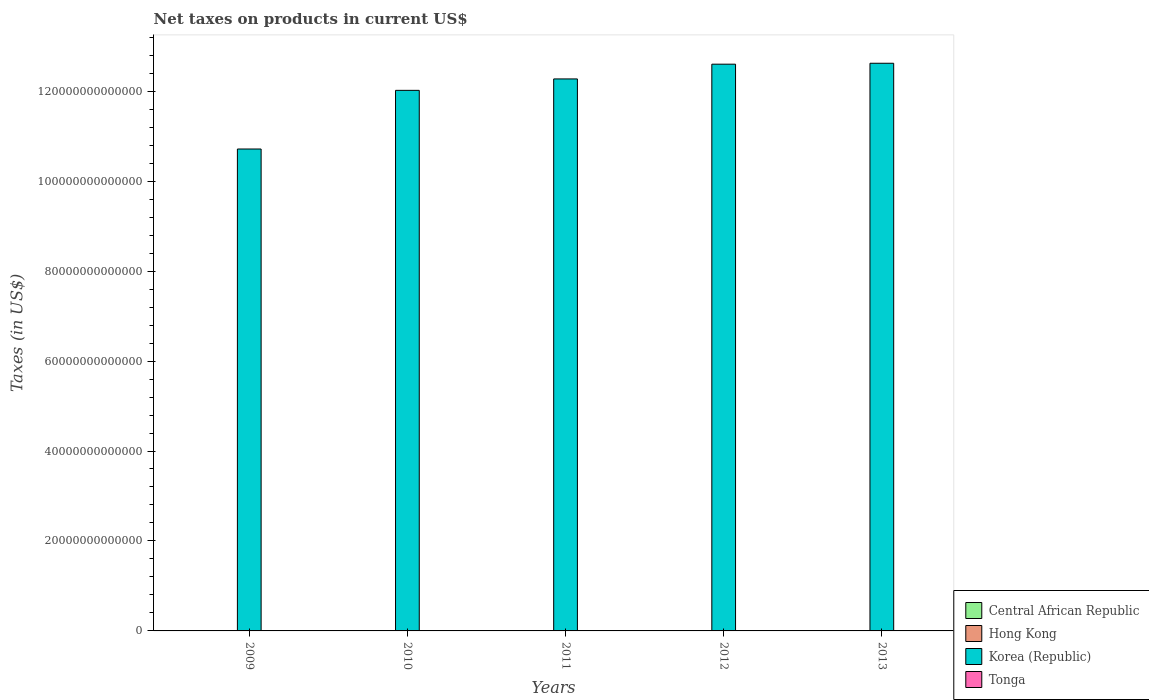How many groups of bars are there?
Provide a short and direct response. 5. Are the number of bars on each tick of the X-axis equal?
Your answer should be compact. Yes. What is the net taxes on products in Korea (Republic) in 2012?
Offer a terse response. 1.26e+14. Across all years, what is the maximum net taxes on products in Tonga?
Your response must be concise. 1.02e+08. Across all years, what is the minimum net taxes on products in Korea (Republic)?
Your response must be concise. 1.07e+14. In which year was the net taxes on products in Hong Kong maximum?
Provide a succinct answer. 2013. What is the total net taxes on products in Korea (Republic) in the graph?
Give a very brief answer. 6.02e+14. What is the difference between the net taxes on products in Hong Kong in 2009 and that in 2010?
Your answer should be compact. -1.40e+1. What is the difference between the net taxes on products in Hong Kong in 2009 and the net taxes on products in Central African Republic in 2012?
Give a very brief answer. -1.08e+1. What is the average net taxes on products in Hong Kong per year?
Your response must be concise. 6.63e+1. In the year 2011, what is the difference between the net taxes on products in Hong Kong and net taxes on products in Central African Republic?
Give a very brief answer. 1.40e+1. What is the ratio of the net taxes on products in Tonga in 2011 to that in 2012?
Offer a very short reply. 0.9. Is the net taxes on products in Central African Republic in 2010 less than that in 2013?
Your response must be concise. No. Is the difference between the net taxes on products in Hong Kong in 2009 and 2013 greater than the difference between the net taxes on products in Central African Republic in 2009 and 2013?
Give a very brief answer. No. What is the difference between the highest and the second highest net taxes on products in Korea (Republic)?
Keep it short and to the point. 2.06e+11. What is the difference between the highest and the lowest net taxes on products in Tonga?
Make the answer very short. 1.73e+07. Is the sum of the net taxes on products in Hong Kong in 2009 and 2010 greater than the maximum net taxes on products in Central African Republic across all years?
Your answer should be very brief. Yes. What does the 2nd bar from the left in 2009 represents?
Keep it short and to the point. Hong Kong. Is it the case that in every year, the sum of the net taxes on products in Tonga and net taxes on products in Hong Kong is greater than the net taxes on products in Korea (Republic)?
Your answer should be compact. No. How many bars are there?
Provide a short and direct response. 20. Are all the bars in the graph horizontal?
Provide a short and direct response. No. What is the difference between two consecutive major ticks on the Y-axis?
Offer a terse response. 2.00e+13. Does the graph contain any zero values?
Your answer should be very brief. No. Does the graph contain grids?
Provide a short and direct response. No. How are the legend labels stacked?
Offer a terse response. Vertical. What is the title of the graph?
Offer a terse response. Net taxes on products in current US$. What is the label or title of the X-axis?
Your answer should be compact. Years. What is the label or title of the Y-axis?
Provide a short and direct response. Taxes (in US$). What is the Taxes (in US$) of Central African Republic in 2009?
Keep it short and to the point. 6.08e+1. What is the Taxes (in US$) of Hong Kong in 2009?
Keep it short and to the point. 5.47e+1. What is the Taxes (in US$) of Korea (Republic) in 2009?
Your answer should be very brief. 1.07e+14. What is the Taxes (in US$) in Tonga in 2009?
Provide a short and direct response. 8.51e+07. What is the Taxes (in US$) in Central African Republic in 2010?
Your answer should be compact. 7.10e+1. What is the Taxes (in US$) in Hong Kong in 2010?
Your response must be concise. 6.87e+1. What is the Taxes (in US$) of Korea (Republic) in 2010?
Your answer should be compact. 1.20e+14. What is the Taxes (in US$) of Tonga in 2010?
Your response must be concise. 8.43e+07. What is the Taxes (in US$) in Central African Republic in 2011?
Your response must be concise. 5.54e+1. What is the Taxes (in US$) in Hong Kong in 2011?
Provide a succinct answer. 6.94e+1. What is the Taxes (in US$) in Korea (Republic) in 2011?
Keep it short and to the point. 1.23e+14. What is the Taxes (in US$) of Tonga in 2011?
Your answer should be compact. 9.14e+07. What is the Taxes (in US$) of Central African Republic in 2012?
Your response must be concise. 6.55e+1. What is the Taxes (in US$) in Hong Kong in 2012?
Keep it short and to the point. 6.36e+1. What is the Taxes (in US$) of Korea (Republic) in 2012?
Your answer should be compact. 1.26e+14. What is the Taxes (in US$) of Tonga in 2012?
Offer a very short reply. 1.01e+08. What is the Taxes (in US$) of Central African Republic in 2013?
Offer a terse response. 3.54e+1. What is the Taxes (in US$) of Hong Kong in 2013?
Give a very brief answer. 7.53e+1. What is the Taxes (in US$) in Korea (Republic) in 2013?
Offer a terse response. 1.26e+14. What is the Taxes (in US$) of Tonga in 2013?
Your response must be concise. 1.02e+08. Across all years, what is the maximum Taxes (in US$) of Central African Republic?
Provide a succinct answer. 7.10e+1. Across all years, what is the maximum Taxes (in US$) in Hong Kong?
Provide a succinct answer. 7.53e+1. Across all years, what is the maximum Taxes (in US$) of Korea (Republic)?
Make the answer very short. 1.26e+14. Across all years, what is the maximum Taxes (in US$) in Tonga?
Your response must be concise. 1.02e+08. Across all years, what is the minimum Taxes (in US$) in Central African Republic?
Your answer should be very brief. 3.54e+1. Across all years, what is the minimum Taxes (in US$) in Hong Kong?
Your answer should be compact. 5.47e+1. Across all years, what is the minimum Taxes (in US$) in Korea (Republic)?
Offer a terse response. 1.07e+14. Across all years, what is the minimum Taxes (in US$) of Tonga?
Your response must be concise. 8.43e+07. What is the total Taxes (in US$) of Central African Republic in the graph?
Give a very brief answer. 2.88e+11. What is the total Taxes (in US$) of Hong Kong in the graph?
Keep it short and to the point. 3.32e+11. What is the total Taxes (in US$) of Korea (Republic) in the graph?
Give a very brief answer. 6.02e+14. What is the total Taxes (in US$) in Tonga in the graph?
Provide a short and direct response. 4.64e+08. What is the difference between the Taxes (in US$) in Central African Republic in 2009 and that in 2010?
Ensure brevity in your answer.  -1.02e+1. What is the difference between the Taxes (in US$) in Hong Kong in 2009 and that in 2010?
Your answer should be very brief. -1.40e+1. What is the difference between the Taxes (in US$) in Korea (Republic) in 2009 and that in 2010?
Offer a very short reply. -1.30e+13. What is the difference between the Taxes (in US$) of Tonga in 2009 and that in 2010?
Offer a terse response. 7.02e+05. What is the difference between the Taxes (in US$) in Central African Republic in 2009 and that in 2011?
Offer a very short reply. 5.40e+09. What is the difference between the Taxes (in US$) of Hong Kong in 2009 and that in 2011?
Give a very brief answer. -1.47e+1. What is the difference between the Taxes (in US$) of Korea (Republic) in 2009 and that in 2011?
Your answer should be compact. -1.56e+13. What is the difference between the Taxes (in US$) in Tonga in 2009 and that in 2011?
Make the answer very short. -6.37e+06. What is the difference between the Taxes (in US$) in Central African Republic in 2009 and that in 2012?
Your answer should be compact. -4.70e+09. What is the difference between the Taxes (in US$) of Hong Kong in 2009 and that in 2012?
Keep it short and to the point. -8.89e+09. What is the difference between the Taxes (in US$) of Korea (Republic) in 2009 and that in 2012?
Ensure brevity in your answer.  -1.89e+13. What is the difference between the Taxes (in US$) in Tonga in 2009 and that in 2012?
Give a very brief answer. -1.60e+07. What is the difference between the Taxes (in US$) in Central African Republic in 2009 and that in 2013?
Make the answer very short. 2.54e+1. What is the difference between the Taxes (in US$) in Hong Kong in 2009 and that in 2013?
Keep it short and to the point. -2.06e+1. What is the difference between the Taxes (in US$) of Korea (Republic) in 2009 and that in 2013?
Offer a terse response. -1.91e+13. What is the difference between the Taxes (in US$) in Tonga in 2009 and that in 2013?
Your answer should be very brief. -1.66e+07. What is the difference between the Taxes (in US$) of Central African Republic in 2010 and that in 2011?
Offer a very short reply. 1.56e+1. What is the difference between the Taxes (in US$) of Hong Kong in 2010 and that in 2011?
Offer a terse response. -6.94e+08. What is the difference between the Taxes (in US$) of Korea (Republic) in 2010 and that in 2011?
Make the answer very short. -2.54e+12. What is the difference between the Taxes (in US$) in Tonga in 2010 and that in 2011?
Your answer should be very brief. -7.07e+06. What is the difference between the Taxes (in US$) of Central African Republic in 2010 and that in 2012?
Give a very brief answer. 5.50e+09. What is the difference between the Taxes (in US$) of Hong Kong in 2010 and that in 2012?
Your answer should be very brief. 5.13e+09. What is the difference between the Taxes (in US$) of Korea (Republic) in 2010 and that in 2012?
Your response must be concise. -5.82e+12. What is the difference between the Taxes (in US$) of Tonga in 2010 and that in 2012?
Make the answer very short. -1.67e+07. What is the difference between the Taxes (in US$) in Central African Republic in 2010 and that in 2013?
Offer a terse response. 3.56e+1. What is the difference between the Taxes (in US$) in Hong Kong in 2010 and that in 2013?
Give a very brief answer. -6.61e+09. What is the difference between the Taxes (in US$) of Korea (Republic) in 2010 and that in 2013?
Give a very brief answer. -6.02e+12. What is the difference between the Taxes (in US$) of Tonga in 2010 and that in 2013?
Keep it short and to the point. -1.73e+07. What is the difference between the Taxes (in US$) of Central African Republic in 2011 and that in 2012?
Provide a short and direct response. -1.01e+1. What is the difference between the Taxes (in US$) in Hong Kong in 2011 and that in 2012?
Give a very brief answer. 5.83e+09. What is the difference between the Taxes (in US$) in Korea (Republic) in 2011 and that in 2012?
Your answer should be compact. -3.28e+12. What is the difference between the Taxes (in US$) in Tonga in 2011 and that in 2012?
Give a very brief answer. -9.67e+06. What is the difference between the Taxes (in US$) in Central African Republic in 2011 and that in 2013?
Ensure brevity in your answer.  2.00e+1. What is the difference between the Taxes (in US$) in Hong Kong in 2011 and that in 2013?
Make the answer very short. -5.91e+09. What is the difference between the Taxes (in US$) in Korea (Republic) in 2011 and that in 2013?
Your response must be concise. -3.48e+12. What is the difference between the Taxes (in US$) in Tonga in 2011 and that in 2013?
Your response must be concise. -1.02e+07. What is the difference between the Taxes (in US$) of Central African Republic in 2012 and that in 2013?
Provide a short and direct response. 3.01e+1. What is the difference between the Taxes (in US$) of Hong Kong in 2012 and that in 2013?
Keep it short and to the point. -1.17e+1. What is the difference between the Taxes (in US$) in Korea (Republic) in 2012 and that in 2013?
Give a very brief answer. -2.06e+11. What is the difference between the Taxes (in US$) in Tonga in 2012 and that in 2013?
Your answer should be compact. -5.48e+05. What is the difference between the Taxes (in US$) of Central African Republic in 2009 and the Taxes (in US$) of Hong Kong in 2010?
Keep it short and to the point. -7.91e+09. What is the difference between the Taxes (in US$) of Central African Republic in 2009 and the Taxes (in US$) of Korea (Republic) in 2010?
Ensure brevity in your answer.  -1.20e+14. What is the difference between the Taxes (in US$) of Central African Republic in 2009 and the Taxes (in US$) of Tonga in 2010?
Provide a short and direct response. 6.07e+1. What is the difference between the Taxes (in US$) of Hong Kong in 2009 and the Taxes (in US$) of Korea (Republic) in 2010?
Make the answer very short. -1.20e+14. What is the difference between the Taxes (in US$) of Hong Kong in 2009 and the Taxes (in US$) of Tonga in 2010?
Make the answer very short. 5.46e+1. What is the difference between the Taxes (in US$) in Korea (Republic) in 2009 and the Taxes (in US$) in Tonga in 2010?
Your answer should be very brief. 1.07e+14. What is the difference between the Taxes (in US$) in Central African Republic in 2009 and the Taxes (in US$) in Hong Kong in 2011?
Make the answer very short. -8.60e+09. What is the difference between the Taxes (in US$) in Central African Republic in 2009 and the Taxes (in US$) in Korea (Republic) in 2011?
Keep it short and to the point. -1.23e+14. What is the difference between the Taxes (in US$) of Central African Republic in 2009 and the Taxes (in US$) of Tonga in 2011?
Make the answer very short. 6.07e+1. What is the difference between the Taxes (in US$) of Hong Kong in 2009 and the Taxes (in US$) of Korea (Republic) in 2011?
Offer a very short reply. -1.23e+14. What is the difference between the Taxes (in US$) in Hong Kong in 2009 and the Taxes (in US$) in Tonga in 2011?
Provide a short and direct response. 5.46e+1. What is the difference between the Taxes (in US$) of Korea (Republic) in 2009 and the Taxes (in US$) of Tonga in 2011?
Your response must be concise. 1.07e+14. What is the difference between the Taxes (in US$) of Central African Republic in 2009 and the Taxes (in US$) of Hong Kong in 2012?
Your answer should be very brief. -2.78e+09. What is the difference between the Taxes (in US$) in Central African Republic in 2009 and the Taxes (in US$) in Korea (Republic) in 2012?
Offer a terse response. -1.26e+14. What is the difference between the Taxes (in US$) of Central African Republic in 2009 and the Taxes (in US$) of Tonga in 2012?
Your response must be concise. 6.07e+1. What is the difference between the Taxes (in US$) of Hong Kong in 2009 and the Taxes (in US$) of Korea (Republic) in 2012?
Make the answer very short. -1.26e+14. What is the difference between the Taxes (in US$) of Hong Kong in 2009 and the Taxes (in US$) of Tonga in 2012?
Ensure brevity in your answer.  5.46e+1. What is the difference between the Taxes (in US$) of Korea (Republic) in 2009 and the Taxes (in US$) of Tonga in 2012?
Your response must be concise. 1.07e+14. What is the difference between the Taxes (in US$) of Central African Republic in 2009 and the Taxes (in US$) of Hong Kong in 2013?
Your response must be concise. -1.45e+1. What is the difference between the Taxes (in US$) of Central African Republic in 2009 and the Taxes (in US$) of Korea (Republic) in 2013?
Make the answer very short. -1.26e+14. What is the difference between the Taxes (in US$) in Central African Republic in 2009 and the Taxes (in US$) in Tonga in 2013?
Ensure brevity in your answer.  6.07e+1. What is the difference between the Taxes (in US$) in Hong Kong in 2009 and the Taxes (in US$) in Korea (Republic) in 2013?
Offer a terse response. -1.26e+14. What is the difference between the Taxes (in US$) of Hong Kong in 2009 and the Taxes (in US$) of Tonga in 2013?
Provide a short and direct response. 5.46e+1. What is the difference between the Taxes (in US$) of Korea (Republic) in 2009 and the Taxes (in US$) of Tonga in 2013?
Your response must be concise. 1.07e+14. What is the difference between the Taxes (in US$) in Central African Republic in 2010 and the Taxes (in US$) in Hong Kong in 2011?
Keep it short and to the point. 1.60e+09. What is the difference between the Taxes (in US$) of Central African Republic in 2010 and the Taxes (in US$) of Korea (Republic) in 2011?
Ensure brevity in your answer.  -1.23e+14. What is the difference between the Taxes (in US$) of Central African Republic in 2010 and the Taxes (in US$) of Tonga in 2011?
Make the answer very short. 7.09e+1. What is the difference between the Taxes (in US$) in Hong Kong in 2010 and the Taxes (in US$) in Korea (Republic) in 2011?
Keep it short and to the point. -1.23e+14. What is the difference between the Taxes (in US$) in Hong Kong in 2010 and the Taxes (in US$) in Tonga in 2011?
Offer a terse response. 6.86e+1. What is the difference between the Taxes (in US$) of Korea (Republic) in 2010 and the Taxes (in US$) of Tonga in 2011?
Make the answer very short. 1.20e+14. What is the difference between the Taxes (in US$) of Central African Republic in 2010 and the Taxes (in US$) of Hong Kong in 2012?
Provide a short and direct response. 7.42e+09. What is the difference between the Taxes (in US$) of Central African Republic in 2010 and the Taxes (in US$) of Korea (Republic) in 2012?
Provide a short and direct response. -1.26e+14. What is the difference between the Taxes (in US$) of Central African Republic in 2010 and the Taxes (in US$) of Tonga in 2012?
Make the answer very short. 7.09e+1. What is the difference between the Taxes (in US$) in Hong Kong in 2010 and the Taxes (in US$) in Korea (Republic) in 2012?
Provide a succinct answer. -1.26e+14. What is the difference between the Taxes (in US$) in Hong Kong in 2010 and the Taxes (in US$) in Tonga in 2012?
Your answer should be very brief. 6.86e+1. What is the difference between the Taxes (in US$) of Korea (Republic) in 2010 and the Taxes (in US$) of Tonga in 2012?
Provide a short and direct response. 1.20e+14. What is the difference between the Taxes (in US$) of Central African Republic in 2010 and the Taxes (in US$) of Hong Kong in 2013?
Your answer should be compact. -4.31e+09. What is the difference between the Taxes (in US$) of Central African Republic in 2010 and the Taxes (in US$) of Korea (Republic) in 2013?
Offer a terse response. -1.26e+14. What is the difference between the Taxes (in US$) of Central African Republic in 2010 and the Taxes (in US$) of Tonga in 2013?
Provide a succinct answer. 7.09e+1. What is the difference between the Taxes (in US$) of Hong Kong in 2010 and the Taxes (in US$) of Korea (Republic) in 2013?
Offer a terse response. -1.26e+14. What is the difference between the Taxes (in US$) in Hong Kong in 2010 and the Taxes (in US$) in Tonga in 2013?
Keep it short and to the point. 6.86e+1. What is the difference between the Taxes (in US$) of Korea (Republic) in 2010 and the Taxes (in US$) of Tonga in 2013?
Offer a terse response. 1.20e+14. What is the difference between the Taxes (in US$) in Central African Republic in 2011 and the Taxes (in US$) in Hong Kong in 2012?
Ensure brevity in your answer.  -8.18e+09. What is the difference between the Taxes (in US$) in Central African Republic in 2011 and the Taxes (in US$) in Korea (Republic) in 2012?
Your answer should be very brief. -1.26e+14. What is the difference between the Taxes (in US$) in Central African Republic in 2011 and the Taxes (in US$) in Tonga in 2012?
Your answer should be compact. 5.53e+1. What is the difference between the Taxes (in US$) in Hong Kong in 2011 and the Taxes (in US$) in Korea (Republic) in 2012?
Make the answer very short. -1.26e+14. What is the difference between the Taxes (in US$) in Hong Kong in 2011 and the Taxes (in US$) in Tonga in 2012?
Keep it short and to the point. 6.93e+1. What is the difference between the Taxes (in US$) of Korea (Republic) in 2011 and the Taxes (in US$) of Tonga in 2012?
Keep it short and to the point. 1.23e+14. What is the difference between the Taxes (in US$) of Central African Republic in 2011 and the Taxes (in US$) of Hong Kong in 2013?
Your answer should be compact. -1.99e+1. What is the difference between the Taxes (in US$) in Central African Republic in 2011 and the Taxes (in US$) in Korea (Republic) in 2013?
Keep it short and to the point. -1.26e+14. What is the difference between the Taxes (in US$) of Central African Republic in 2011 and the Taxes (in US$) of Tonga in 2013?
Offer a terse response. 5.53e+1. What is the difference between the Taxes (in US$) in Hong Kong in 2011 and the Taxes (in US$) in Korea (Republic) in 2013?
Keep it short and to the point. -1.26e+14. What is the difference between the Taxes (in US$) of Hong Kong in 2011 and the Taxes (in US$) of Tonga in 2013?
Provide a short and direct response. 6.93e+1. What is the difference between the Taxes (in US$) in Korea (Republic) in 2011 and the Taxes (in US$) in Tonga in 2013?
Ensure brevity in your answer.  1.23e+14. What is the difference between the Taxes (in US$) in Central African Republic in 2012 and the Taxes (in US$) in Hong Kong in 2013?
Provide a succinct answer. -9.81e+09. What is the difference between the Taxes (in US$) in Central African Republic in 2012 and the Taxes (in US$) in Korea (Republic) in 2013?
Your answer should be very brief. -1.26e+14. What is the difference between the Taxes (in US$) of Central African Republic in 2012 and the Taxes (in US$) of Tonga in 2013?
Offer a terse response. 6.54e+1. What is the difference between the Taxes (in US$) of Hong Kong in 2012 and the Taxes (in US$) of Korea (Republic) in 2013?
Offer a terse response. -1.26e+14. What is the difference between the Taxes (in US$) of Hong Kong in 2012 and the Taxes (in US$) of Tonga in 2013?
Offer a terse response. 6.35e+1. What is the difference between the Taxes (in US$) in Korea (Republic) in 2012 and the Taxes (in US$) in Tonga in 2013?
Provide a succinct answer. 1.26e+14. What is the average Taxes (in US$) in Central African Republic per year?
Ensure brevity in your answer.  5.76e+1. What is the average Taxes (in US$) in Hong Kong per year?
Your response must be concise. 6.63e+1. What is the average Taxes (in US$) in Korea (Republic) per year?
Provide a short and direct response. 1.20e+14. What is the average Taxes (in US$) of Tonga per year?
Ensure brevity in your answer.  9.27e+07. In the year 2009, what is the difference between the Taxes (in US$) of Central African Republic and Taxes (in US$) of Hong Kong?
Keep it short and to the point. 6.11e+09. In the year 2009, what is the difference between the Taxes (in US$) in Central African Republic and Taxes (in US$) in Korea (Republic)?
Make the answer very short. -1.07e+14. In the year 2009, what is the difference between the Taxes (in US$) of Central African Republic and Taxes (in US$) of Tonga?
Give a very brief answer. 6.07e+1. In the year 2009, what is the difference between the Taxes (in US$) in Hong Kong and Taxes (in US$) in Korea (Republic)?
Offer a very short reply. -1.07e+14. In the year 2009, what is the difference between the Taxes (in US$) in Hong Kong and Taxes (in US$) in Tonga?
Offer a very short reply. 5.46e+1. In the year 2009, what is the difference between the Taxes (in US$) in Korea (Republic) and Taxes (in US$) in Tonga?
Provide a short and direct response. 1.07e+14. In the year 2010, what is the difference between the Taxes (in US$) of Central African Republic and Taxes (in US$) of Hong Kong?
Offer a very short reply. 2.29e+09. In the year 2010, what is the difference between the Taxes (in US$) in Central African Republic and Taxes (in US$) in Korea (Republic)?
Offer a very short reply. -1.20e+14. In the year 2010, what is the difference between the Taxes (in US$) in Central African Republic and Taxes (in US$) in Tonga?
Give a very brief answer. 7.09e+1. In the year 2010, what is the difference between the Taxes (in US$) of Hong Kong and Taxes (in US$) of Korea (Republic)?
Provide a short and direct response. -1.20e+14. In the year 2010, what is the difference between the Taxes (in US$) in Hong Kong and Taxes (in US$) in Tonga?
Provide a short and direct response. 6.86e+1. In the year 2010, what is the difference between the Taxes (in US$) in Korea (Republic) and Taxes (in US$) in Tonga?
Provide a short and direct response. 1.20e+14. In the year 2011, what is the difference between the Taxes (in US$) in Central African Republic and Taxes (in US$) in Hong Kong?
Your response must be concise. -1.40e+1. In the year 2011, what is the difference between the Taxes (in US$) in Central African Republic and Taxes (in US$) in Korea (Republic)?
Your response must be concise. -1.23e+14. In the year 2011, what is the difference between the Taxes (in US$) of Central African Republic and Taxes (in US$) of Tonga?
Offer a very short reply. 5.53e+1. In the year 2011, what is the difference between the Taxes (in US$) of Hong Kong and Taxes (in US$) of Korea (Republic)?
Keep it short and to the point. -1.23e+14. In the year 2011, what is the difference between the Taxes (in US$) of Hong Kong and Taxes (in US$) of Tonga?
Offer a very short reply. 6.93e+1. In the year 2011, what is the difference between the Taxes (in US$) of Korea (Republic) and Taxes (in US$) of Tonga?
Keep it short and to the point. 1.23e+14. In the year 2012, what is the difference between the Taxes (in US$) of Central African Republic and Taxes (in US$) of Hong Kong?
Your answer should be very brief. 1.92e+09. In the year 2012, what is the difference between the Taxes (in US$) of Central African Republic and Taxes (in US$) of Korea (Republic)?
Ensure brevity in your answer.  -1.26e+14. In the year 2012, what is the difference between the Taxes (in US$) in Central African Republic and Taxes (in US$) in Tonga?
Provide a short and direct response. 6.54e+1. In the year 2012, what is the difference between the Taxes (in US$) of Hong Kong and Taxes (in US$) of Korea (Republic)?
Offer a terse response. -1.26e+14. In the year 2012, what is the difference between the Taxes (in US$) of Hong Kong and Taxes (in US$) of Tonga?
Give a very brief answer. 6.35e+1. In the year 2012, what is the difference between the Taxes (in US$) in Korea (Republic) and Taxes (in US$) in Tonga?
Your answer should be very brief. 1.26e+14. In the year 2013, what is the difference between the Taxes (in US$) of Central African Republic and Taxes (in US$) of Hong Kong?
Offer a very short reply. -3.99e+1. In the year 2013, what is the difference between the Taxes (in US$) in Central African Republic and Taxes (in US$) in Korea (Republic)?
Your answer should be compact. -1.26e+14. In the year 2013, what is the difference between the Taxes (in US$) in Central African Republic and Taxes (in US$) in Tonga?
Your response must be concise. 3.53e+1. In the year 2013, what is the difference between the Taxes (in US$) in Hong Kong and Taxes (in US$) in Korea (Republic)?
Keep it short and to the point. -1.26e+14. In the year 2013, what is the difference between the Taxes (in US$) in Hong Kong and Taxes (in US$) in Tonga?
Ensure brevity in your answer.  7.52e+1. In the year 2013, what is the difference between the Taxes (in US$) in Korea (Republic) and Taxes (in US$) in Tonga?
Provide a short and direct response. 1.26e+14. What is the ratio of the Taxes (in US$) of Central African Republic in 2009 to that in 2010?
Provide a short and direct response. 0.86. What is the ratio of the Taxes (in US$) of Hong Kong in 2009 to that in 2010?
Provide a succinct answer. 0.8. What is the ratio of the Taxes (in US$) of Korea (Republic) in 2009 to that in 2010?
Keep it short and to the point. 0.89. What is the ratio of the Taxes (in US$) of Tonga in 2009 to that in 2010?
Offer a very short reply. 1.01. What is the ratio of the Taxes (in US$) of Central African Republic in 2009 to that in 2011?
Offer a terse response. 1.1. What is the ratio of the Taxes (in US$) of Hong Kong in 2009 to that in 2011?
Make the answer very short. 0.79. What is the ratio of the Taxes (in US$) of Korea (Republic) in 2009 to that in 2011?
Make the answer very short. 0.87. What is the ratio of the Taxes (in US$) of Tonga in 2009 to that in 2011?
Provide a short and direct response. 0.93. What is the ratio of the Taxes (in US$) of Central African Republic in 2009 to that in 2012?
Keep it short and to the point. 0.93. What is the ratio of the Taxes (in US$) of Hong Kong in 2009 to that in 2012?
Your answer should be very brief. 0.86. What is the ratio of the Taxes (in US$) in Korea (Republic) in 2009 to that in 2012?
Your answer should be very brief. 0.85. What is the ratio of the Taxes (in US$) of Tonga in 2009 to that in 2012?
Give a very brief answer. 0.84. What is the ratio of the Taxes (in US$) of Central African Republic in 2009 to that in 2013?
Offer a terse response. 1.72. What is the ratio of the Taxes (in US$) of Hong Kong in 2009 to that in 2013?
Your response must be concise. 0.73. What is the ratio of the Taxes (in US$) of Korea (Republic) in 2009 to that in 2013?
Provide a short and direct response. 0.85. What is the ratio of the Taxes (in US$) of Tonga in 2009 to that in 2013?
Give a very brief answer. 0.84. What is the ratio of the Taxes (in US$) in Central African Republic in 2010 to that in 2011?
Give a very brief answer. 1.28. What is the ratio of the Taxes (in US$) of Hong Kong in 2010 to that in 2011?
Your response must be concise. 0.99. What is the ratio of the Taxes (in US$) of Korea (Republic) in 2010 to that in 2011?
Your answer should be compact. 0.98. What is the ratio of the Taxes (in US$) in Tonga in 2010 to that in 2011?
Give a very brief answer. 0.92. What is the ratio of the Taxes (in US$) of Central African Republic in 2010 to that in 2012?
Provide a succinct answer. 1.08. What is the ratio of the Taxes (in US$) in Hong Kong in 2010 to that in 2012?
Keep it short and to the point. 1.08. What is the ratio of the Taxes (in US$) in Korea (Republic) in 2010 to that in 2012?
Your answer should be very brief. 0.95. What is the ratio of the Taxes (in US$) in Tonga in 2010 to that in 2012?
Ensure brevity in your answer.  0.83. What is the ratio of the Taxes (in US$) of Central African Republic in 2010 to that in 2013?
Provide a succinct answer. 2. What is the ratio of the Taxes (in US$) of Hong Kong in 2010 to that in 2013?
Offer a very short reply. 0.91. What is the ratio of the Taxes (in US$) in Korea (Republic) in 2010 to that in 2013?
Offer a very short reply. 0.95. What is the ratio of the Taxes (in US$) in Tonga in 2010 to that in 2013?
Give a very brief answer. 0.83. What is the ratio of the Taxes (in US$) in Central African Republic in 2011 to that in 2012?
Give a very brief answer. 0.85. What is the ratio of the Taxes (in US$) of Hong Kong in 2011 to that in 2012?
Your response must be concise. 1.09. What is the ratio of the Taxes (in US$) of Korea (Republic) in 2011 to that in 2012?
Offer a terse response. 0.97. What is the ratio of the Taxes (in US$) of Tonga in 2011 to that in 2012?
Your answer should be compact. 0.9. What is the ratio of the Taxes (in US$) of Central African Republic in 2011 to that in 2013?
Your answer should be compact. 1.56. What is the ratio of the Taxes (in US$) of Hong Kong in 2011 to that in 2013?
Your response must be concise. 0.92. What is the ratio of the Taxes (in US$) of Korea (Republic) in 2011 to that in 2013?
Ensure brevity in your answer.  0.97. What is the ratio of the Taxes (in US$) of Tonga in 2011 to that in 2013?
Make the answer very short. 0.9. What is the ratio of the Taxes (in US$) in Central African Republic in 2012 to that in 2013?
Provide a short and direct response. 1.85. What is the ratio of the Taxes (in US$) of Hong Kong in 2012 to that in 2013?
Your answer should be very brief. 0.84. What is the difference between the highest and the second highest Taxes (in US$) of Central African Republic?
Keep it short and to the point. 5.50e+09. What is the difference between the highest and the second highest Taxes (in US$) in Hong Kong?
Provide a short and direct response. 5.91e+09. What is the difference between the highest and the second highest Taxes (in US$) in Korea (Republic)?
Provide a short and direct response. 2.06e+11. What is the difference between the highest and the second highest Taxes (in US$) of Tonga?
Keep it short and to the point. 5.48e+05. What is the difference between the highest and the lowest Taxes (in US$) of Central African Republic?
Ensure brevity in your answer.  3.56e+1. What is the difference between the highest and the lowest Taxes (in US$) of Hong Kong?
Your answer should be very brief. 2.06e+1. What is the difference between the highest and the lowest Taxes (in US$) of Korea (Republic)?
Your answer should be very brief. 1.91e+13. What is the difference between the highest and the lowest Taxes (in US$) in Tonga?
Give a very brief answer. 1.73e+07. 